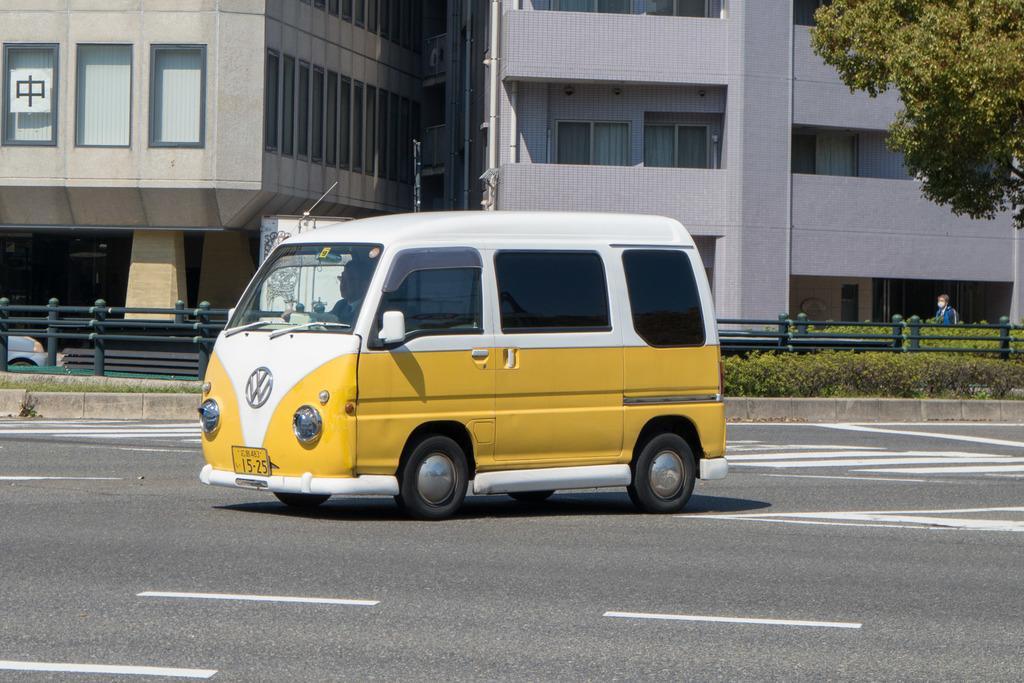Describe this image in one or two sentences. In this picture I can observe a vehicle on the road in the middle of the picture. On the right side I can observe plants and tree. In the background I can observe buildings. 